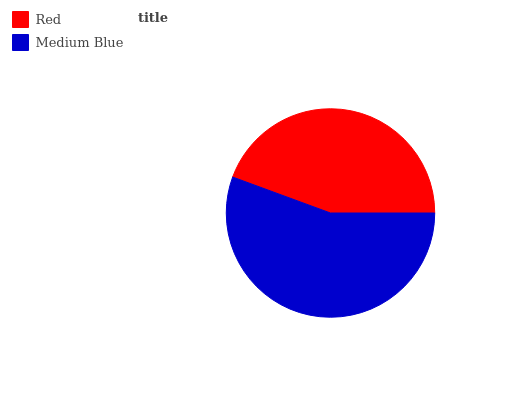Is Red the minimum?
Answer yes or no. Yes. Is Medium Blue the maximum?
Answer yes or no. Yes. Is Medium Blue the minimum?
Answer yes or no. No. Is Medium Blue greater than Red?
Answer yes or no. Yes. Is Red less than Medium Blue?
Answer yes or no. Yes. Is Red greater than Medium Blue?
Answer yes or no. No. Is Medium Blue less than Red?
Answer yes or no. No. Is Medium Blue the high median?
Answer yes or no. Yes. Is Red the low median?
Answer yes or no. Yes. Is Red the high median?
Answer yes or no. No. Is Medium Blue the low median?
Answer yes or no. No. 